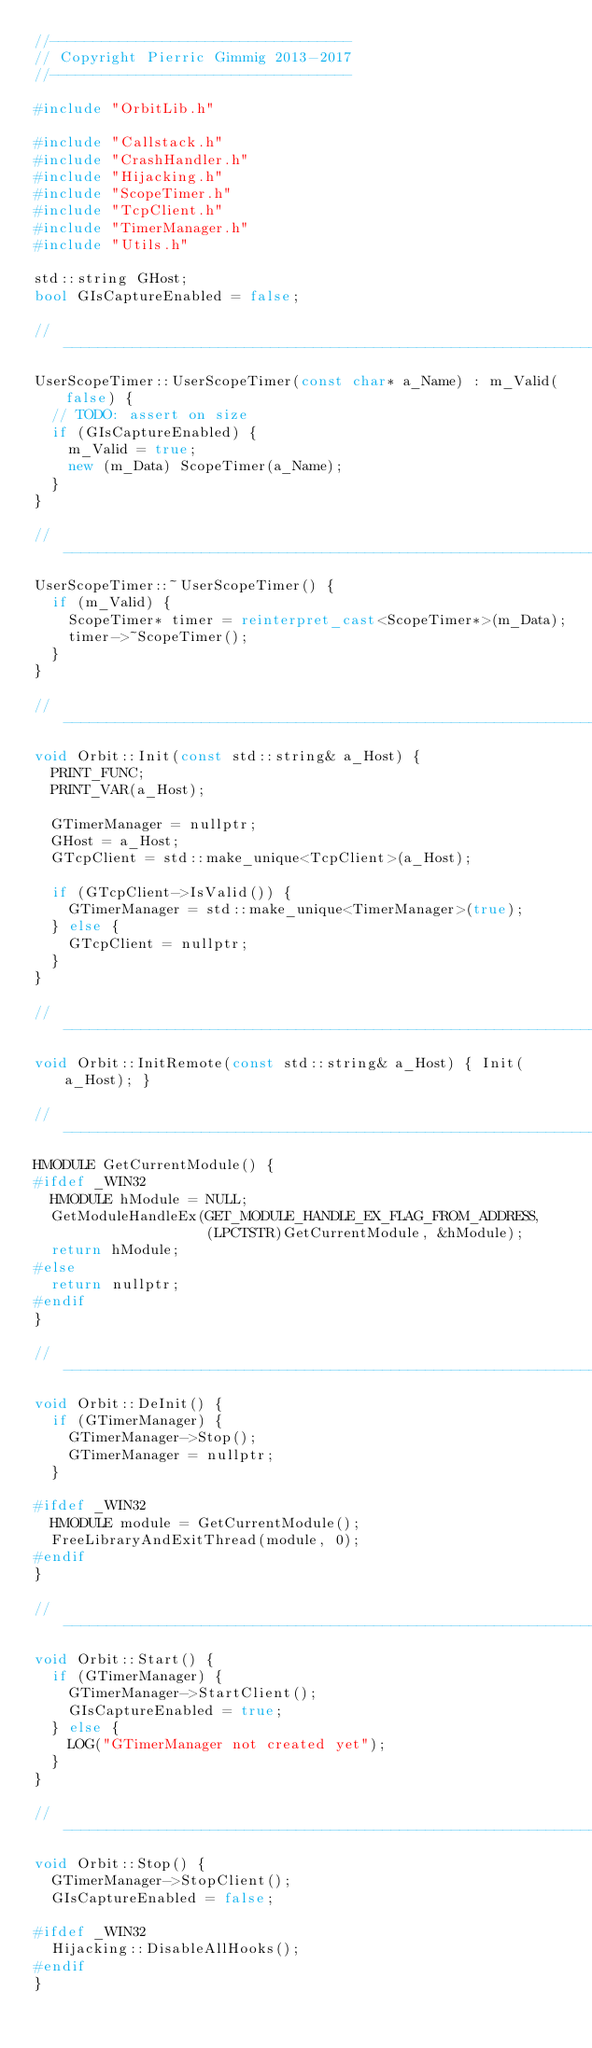Convert code to text. <code><loc_0><loc_0><loc_500><loc_500><_C++_>//-----------------------------------
// Copyright Pierric Gimmig 2013-2017
//-----------------------------------

#include "OrbitLib.h"

#include "Callstack.h"
#include "CrashHandler.h"
#include "Hijacking.h"
#include "ScopeTimer.h"
#include "TcpClient.h"
#include "TimerManager.h"
#include "Utils.h"

std::string GHost;
bool GIsCaptureEnabled = false;

//-----------------------------------------------------------------------------
UserScopeTimer::UserScopeTimer(const char* a_Name) : m_Valid(false) {
  // TODO: assert on size
  if (GIsCaptureEnabled) {
    m_Valid = true;
    new (m_Data) ScopeTimer(a_Name);
  }
}

//-----------------------------------------------------------------------------
UserScopeTimer::~UserScopeTimer() {
  if (m_Valid) {
    ScopeTimer* timer = reinterpret_cast<ScopeTimer*>(m_Data);
    timer->~ScopeTimer();
  }
}

//-----------------------------------------------------------------------------
void Orbit::Init(const std::string& a_Host) {
  PRINT_FUNC;
  PRINT_VAR(a_Host);

  GTimerManager = nullptr;
  GHost = a_Host;
  GTcpClient = std::make_unique<TcpClient>(a_Host);

  if (GTcpClient->IsValid()) {
    GTimerManager = std::make_unique<TimerManager>(true);
  } else {
    GTcpClient = nullptr;
  }
}

//-----------------------------------------------------------------------------
void Orbit::InitRemote(const std::string& a_Host) { Init(a_Host); }

//-----------------------------------------------------------------------------
HMODULE GetCurrentModule() {
#ifdef _WIN32
  HMODULE hModule = NULL;
  GetModuleHandleEx(GET_MODULE_HANDLE_EX_FLAG_FROM_ADDRESS,
                    (LPCTSTR)GetCurrentModule, &hModule);
  return hModule;
#else
  return nullptr;
#endif
}

//-----------------------------------------------------------------------------
void Orbit::DeInit() {
  if (GTimerManager) {
    GTimerManager->Stop();
    GTimerManager = nullptr;
  }

#ifdef _WIN32
  HMODULE module = GetCurrentModule();
  FreeLibraryAndExitThread(module, 0);
#endif
}

//-----------------------------------------------------------------------------
void Orbit::Start() {
  if (GTimerManager) {
    GTimerManager->StartClient();
    GIsCaptureEnabled = true;
  } else {
    LOG("GTimerManager not created yet");
  }
}

//-----------------------------------------------------------------------------
void Orbit::Stop() {
  GTimerManager->StopClient();
  GIsCaptureEnabled = false;

#ifdef _WIN32
  Hijacking::DisableAllHooks();
#endif
}
</code> 